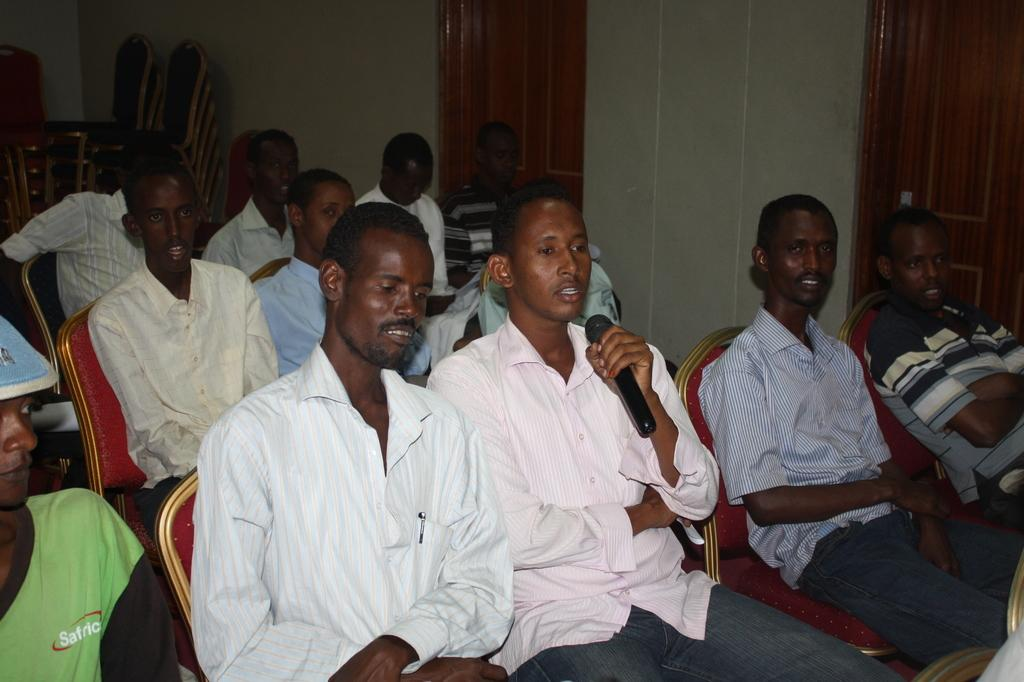What are the people in the image doing? The people in the image are sitting on chairs. Can you describe the person holding an object in the image? There is a person holding a microphone in the image. What can be seen in the background of the image? There is a wall and doors in the background of the image. Are there any other chairs visible in the image? Yes, there are additional chairs in the background of the image. What type of sock is the person wearing on their left foot in the image? There is no information about socks or feet in the image, so it cannot be determined what type of sock the person might be wearing. 